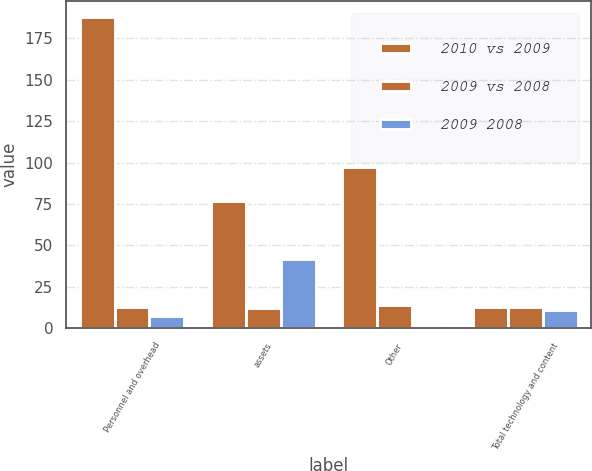Convert chart. <chart><loc_0><loc_0><loc_500><loc_500><stacked_bar_chart><ecel><fcel>Personnel and overhead<fcel>assets<fcel>Other<fcel>Total technology and content<nl><fcel>2010 vs 2009<fcel>188<fcel>77<fcel>97<fcel>13<nl><fcel>2009 vs 2008<fcel>13<fcel>12<fcel>14<fcel>13<nl><fcel>2009 2008<fcel>7<fcel>42<fcel>2<fcel>11<nl></chart> 